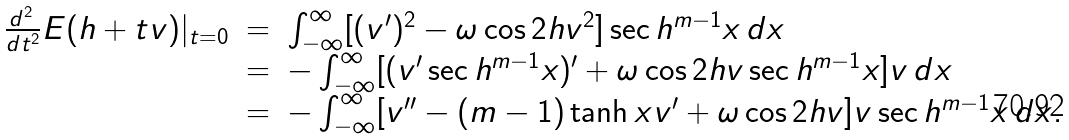Convert formula to latex. <formula><loc_0><loc_0><loc_500><loc_500>\begin{array} { r c l } \frac { d ^ { 2 } \, } { d t ^ { 2 } } E ( h + t v ) | _ { t = 0 } & = & \int _ { - \infty } ^ { \infty } [ ( v ^ { \prime } ) ^ { 2 } - \omega \cos { 2 h } v ^ { 2 } ] \sec h ^ { m - 1 } x \, d x \\ & = & - \int _ { - \infty } ^ { \infty } [ ( v ^ { \prime } \sec h ^ { m - 1 } x ) ^ { \prime } + \omega \cos { 2 h } v \sec h ^ { m - 1 } x ] v \, d x \\ & = & - \int _ { - \infty } ^ { \infty } [ v ^ { \prime \prime } - ( m - 1 ) \tanh { x } v ^ { \prime } + \omega \cos { 2 h } v ] v \sec h ^ { m - 1 } x \, d x . \end{array}</formula> 